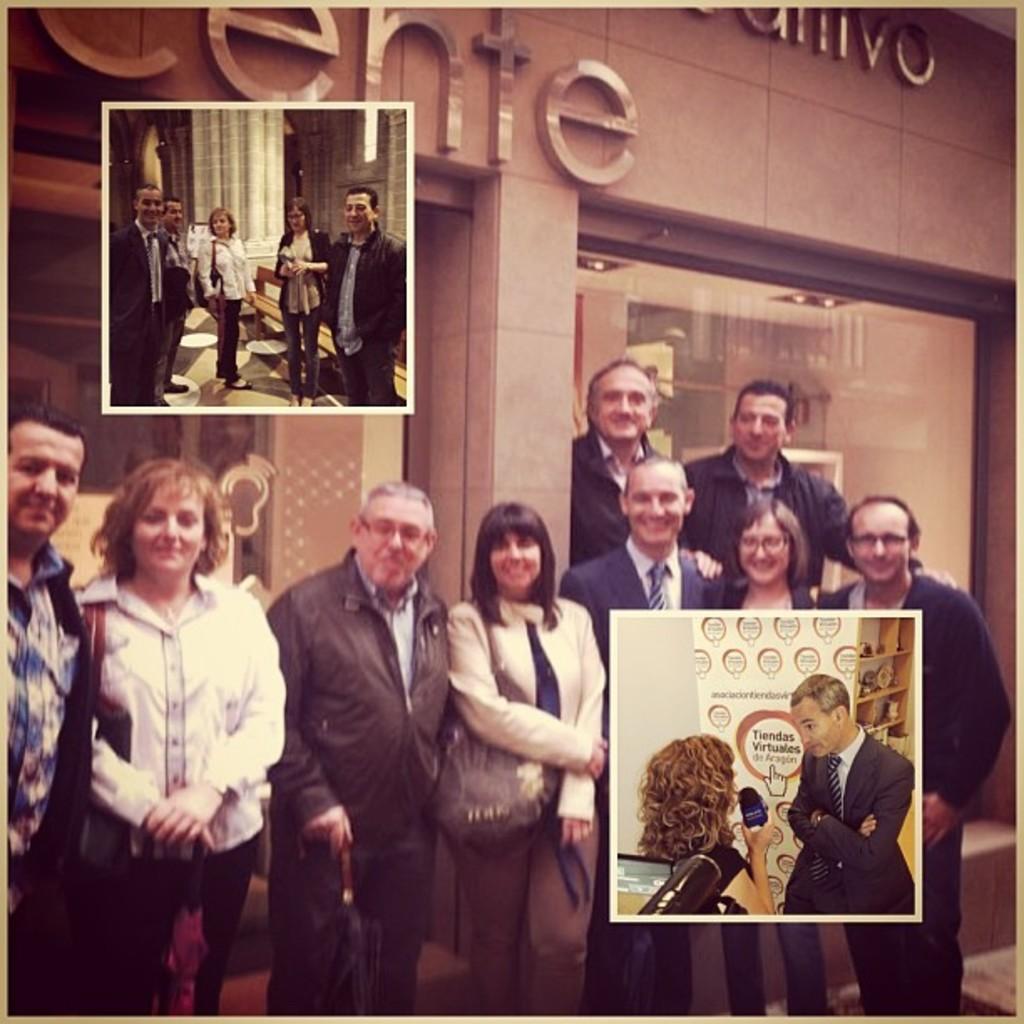How would you summarize this image in a sentence or two? In this image I can see few people standing and wearing different color dress. I can see a building and glass window. 